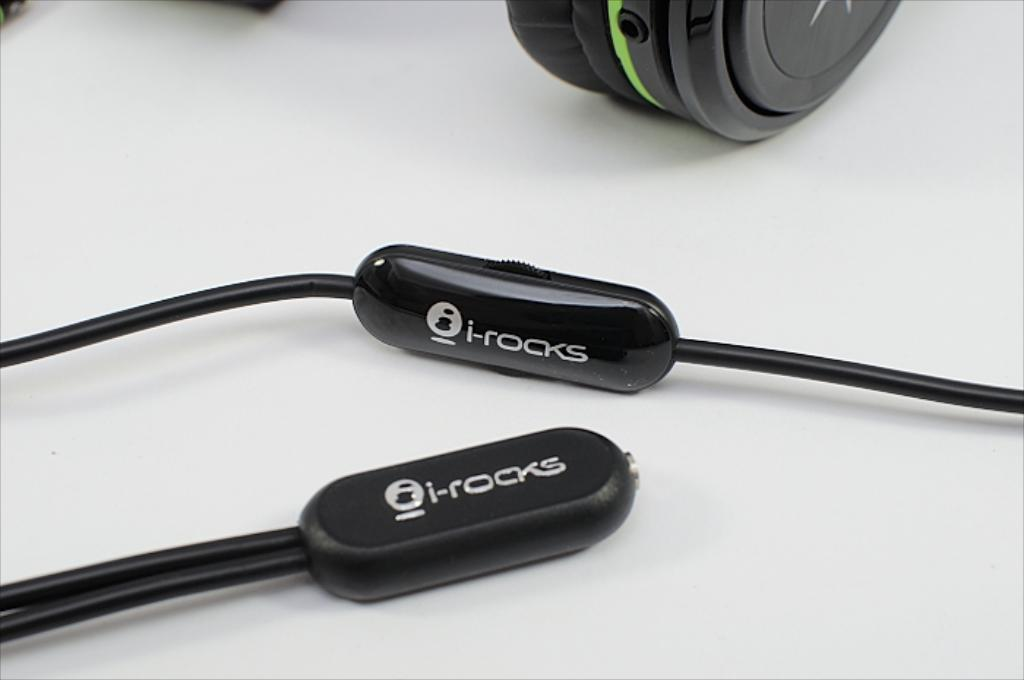<image>
Write a terse but informative summary of the picture. A black i-rocks headphone controller is shown up close next to another i-rocks connector. 